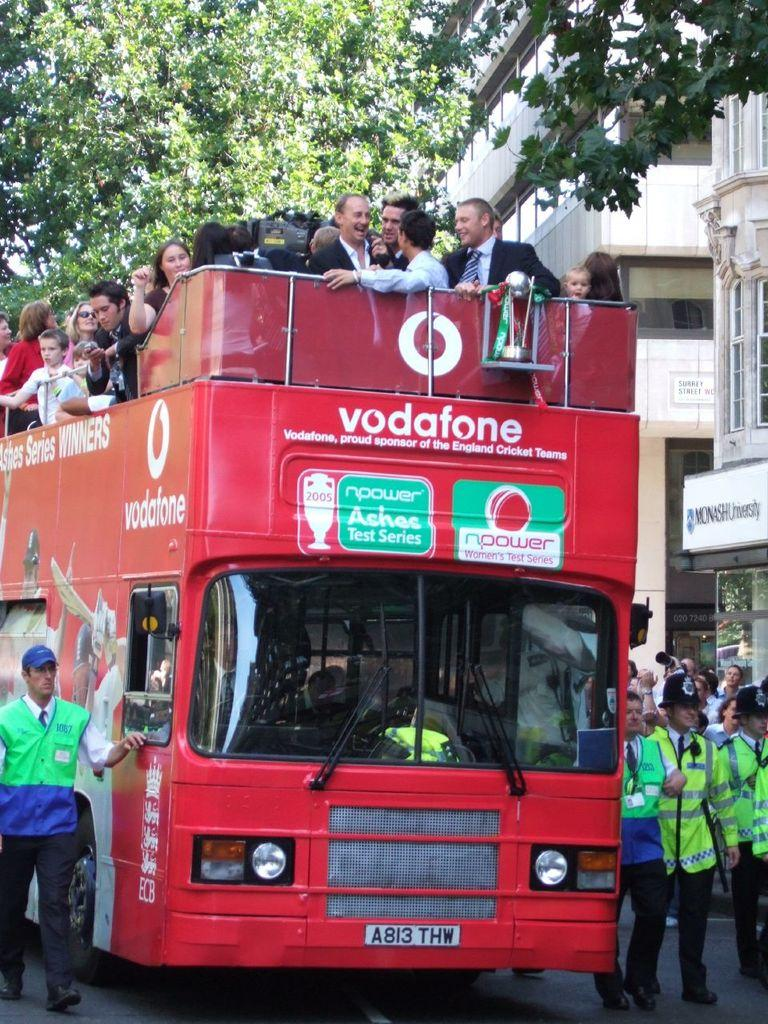What is the main subject in the center of the image? There is a red color bus in the center of the image. What can be seen inside the bus? There are people inside the bus. What are the people outside the bus doing? There are people walking on the road. What can be seen in the background of the image? There are buildings and trees in the background of the image. What news is being discussed by the people walking on the road in the image? There is no indication of any news being discussed by the people walking on the road in the image. What story is being told by the trees in the background of the image? The trees in the background of the image are not telling any story; they are simply part of the scenery. 